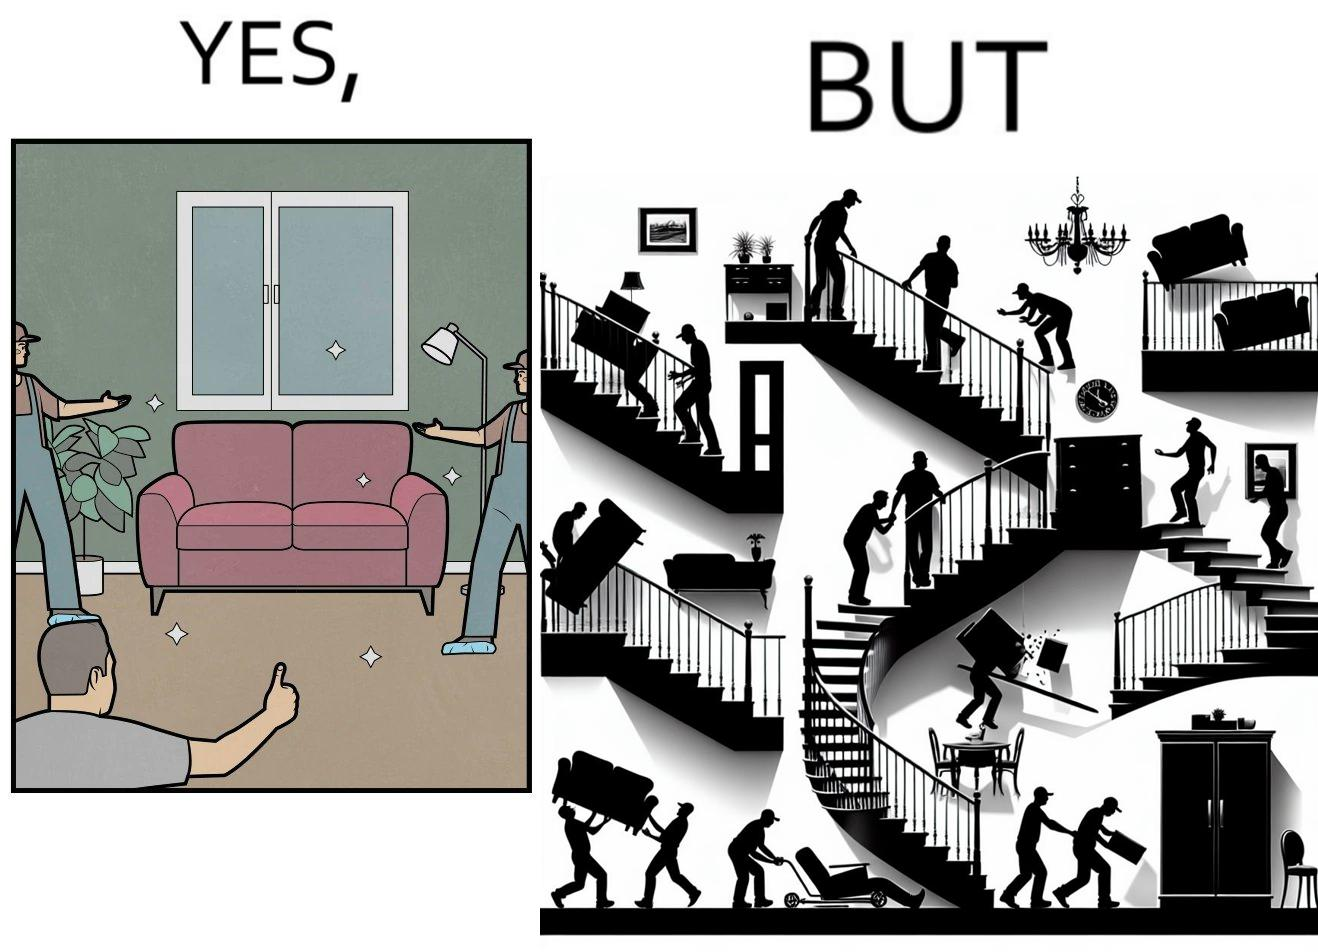Explain the humor or irony in this image. The images are funny since they show how even though the hired movers achieve their task of moving in furniture, in the process, the cause damage to the whole house 